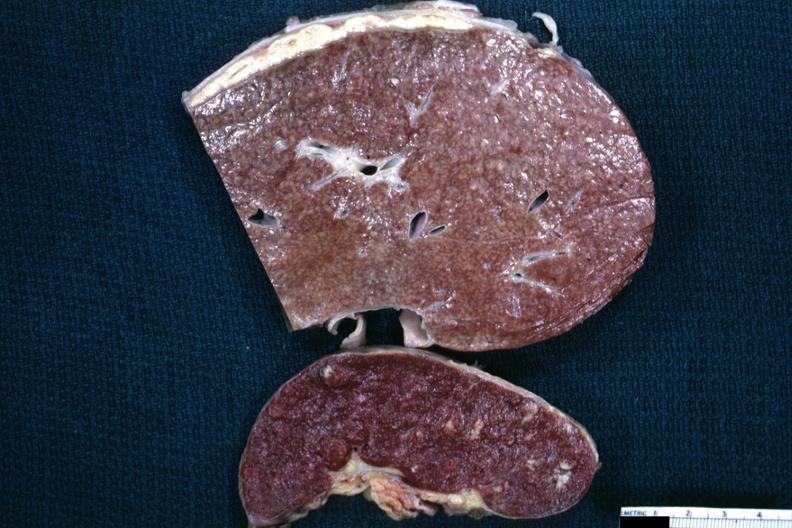s abdomen present?
Answer the question using a single word or phrase. Yes 